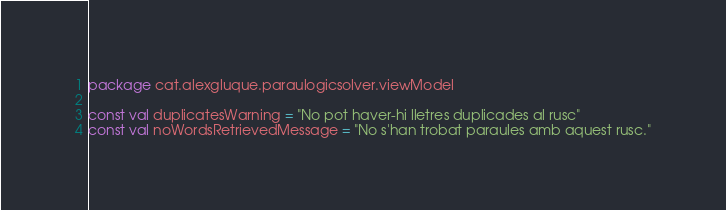Convert code to text. <code><loc_0><loc_0><loc_500><loc_500><_Kotlin_>package cat.alexgluque.paraulogicsolver.viewModel

const val duplicatesWarning = "No pot haver-hi lletres duplicades al rusc"
const val noWordsRetrievedMessage = "No s'han trobat paraules amb aquest rusc."</code> 